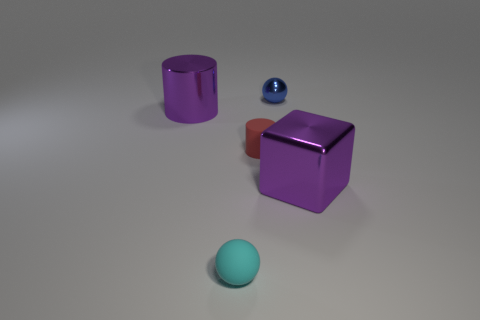Add 4 large purple cylinders. How many objects exist? 9 Subtract all blocks. How many objects are left? 4 Add 5 big purple blocks. How many big purple blocks exist? 6 Subtract 0 purple spheres. How many objects are left? 5 Subtract all tiny cyan matte cylinders. Subtract all big purple shiny cylinders. How many objects are left? 4 Add 5 big purple cubes. How many big purple cubes are left? 6 